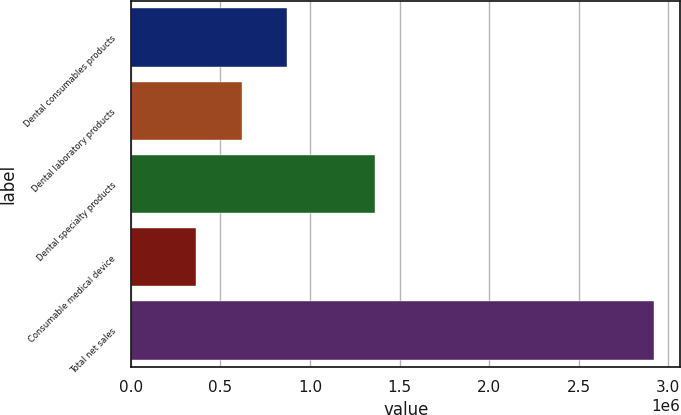Convert chart. <chart><loc_0><loc_0><loc_500><loc_500><bar_chart><fcel>Dental consumables products<fcel>Dental laboratory products<fcel>Dental specialty products<fcel>Consumable medical device<fcel>Total net sales<nl><fcel>873582<fcel>617453<fcel>1.3644e+06<fcel>361323<fcel>2.92262e+06<nl></chart> 